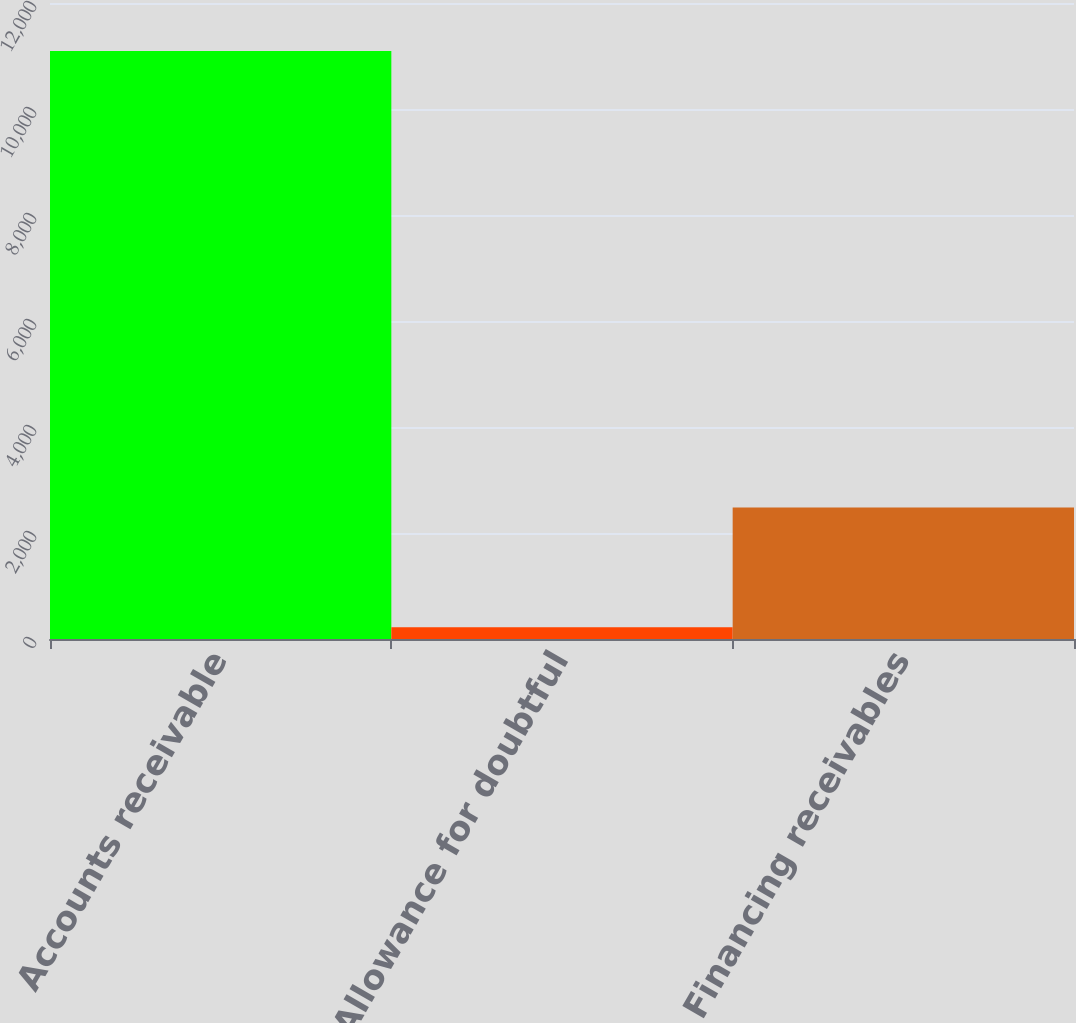Convert chart. <chart><loc_0><loc_0><loc_500><loc_500><bar_chart><fcel>Accounts receivable<fcel>Allowance for doubtful<fcel>Financing receivables<nl><fcel>11093<fcel>220<fcel>2480<nl></chart> 